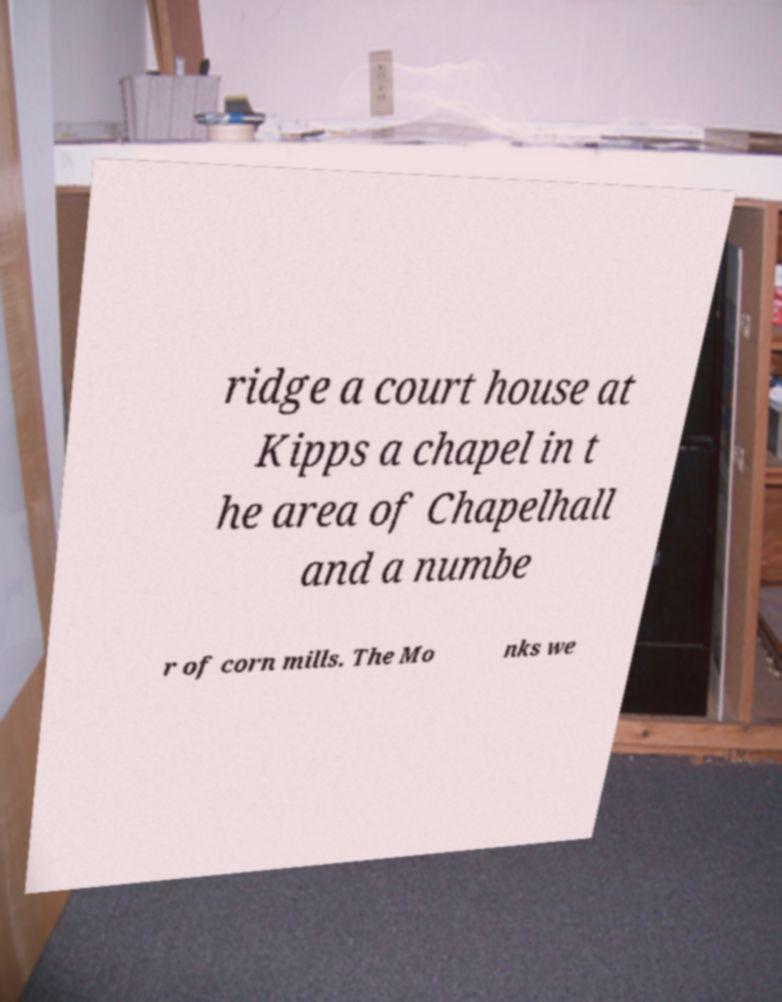What messages or text are displayed in this image? I need them in a readable, typed format. ridge a court house at Kipps a chapel in t he area of Chapelhall and a numbe r of corn mills. The Mo nks we 